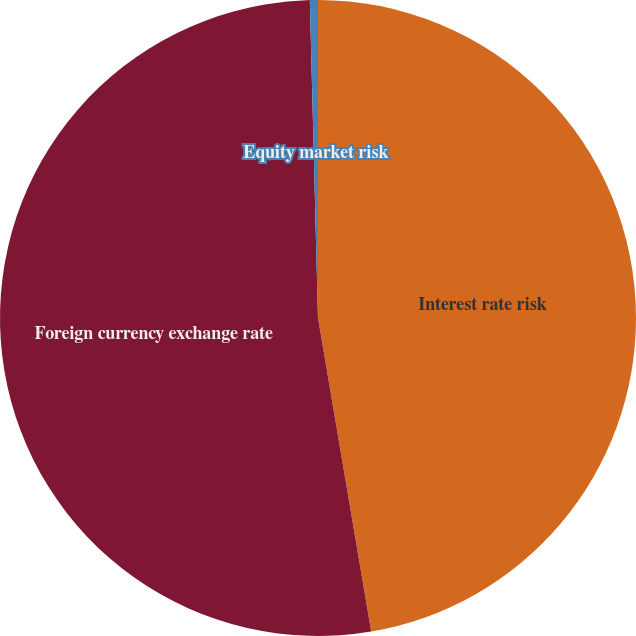<chart> <loc_0><loc_0><loc_500><loc_500><pie_chart><fcel>Interest rate risk<fcel>Foreign currency exchange rate<fcel>Equity market risk<nl><fcel>47.33%<fcel>52.27%<fcel>0.41%<nl></chart> 